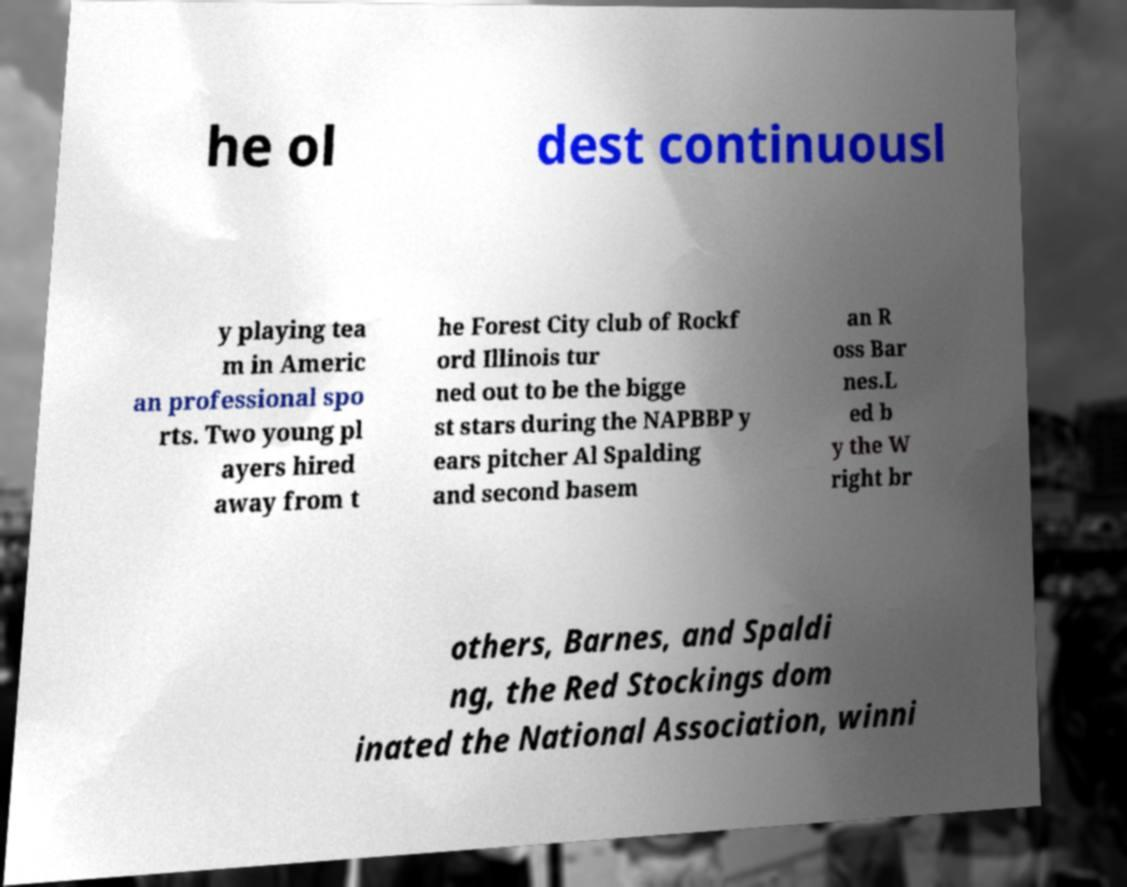Please read and relay the text visible in this image. What does it say? he ol dest continuousl y playing tea m in Americ an professional spo rts. Two young pl ayers hired away from t he Forest City club of Rockf ord Illinois tur ned out to be the bigge st stars during the NAPBBP y ears pitcher Al Spalding and second basem an R oss Bar nes.L ed b y the W right br others, Barnes, and Spaldi ng, the Red Stockings dom inated the National Association, winni 